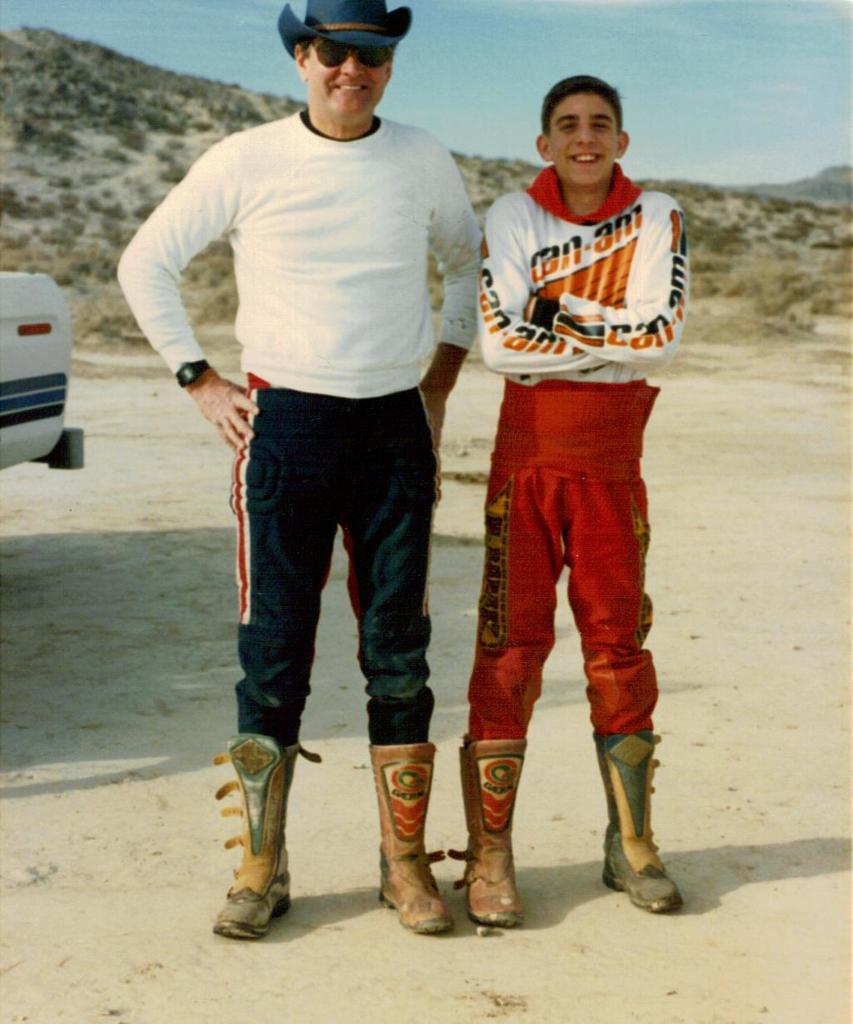<image>
Create a compact narrative representing the image presented. A boy in a shirt that says Can-An1 poses for a photo with a man. 